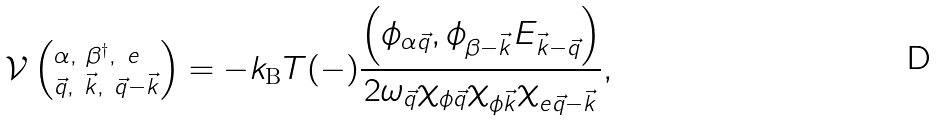Convert formula to latex. <formula><loc_0><loc_0><loc_500><loc_500>\mathcal { V } \left ( _ { \vec { q } , \ \vec { k } , \ \vec { q } - \vec { k } } ^ { \alpha , \ \beta ^ { \dagger } , \ e } \right ) = - k _ { \text  B}T(-) \frac{ \left(\phi_{\alpha\vec{q}} , \phi _ { \beta - \vec { k } } E _ { \vec { k } - \vec { q } } \right ) } { 2 \omega _ { \vec { q } } \chi _ { \phi \vec { q } } \chi _ { \phi \vec { k } } \chi _ { e \vec { q } - \vec { k } } } ,</formula> 